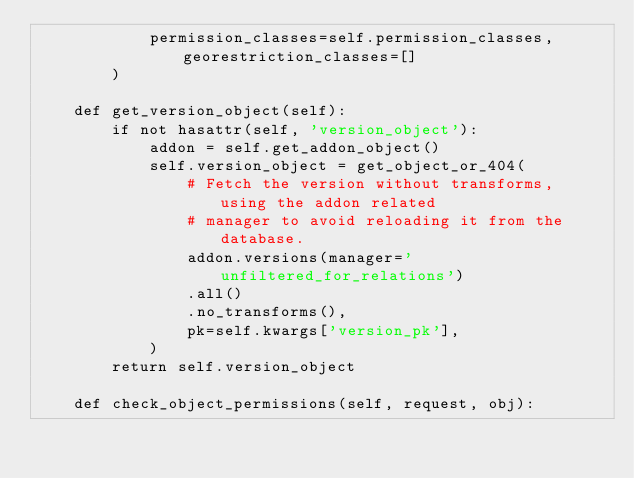<code> <loc_0><loc_0><loc_500><loc_500><_Python_>            permission_classes=self.permission_classes, georestriction_classes=[]
        )

    def get_version_object(self):
        if not hasattr(self, 'version_object'):
            addon = self.get_addon_object()
            self.version_object = get_object_or_404(
                # Fetch the version without transforms, using the addon related
                # manager to avoid reloading it from the database.
                addon.versions(manager='unfiltered_for_relations')
                .all()
                .no_transforms(),
                pk=self.kwargs['version_pk'],
            )
        return self.version_object

    def check_object_permissions(self, request, obj):</code> 